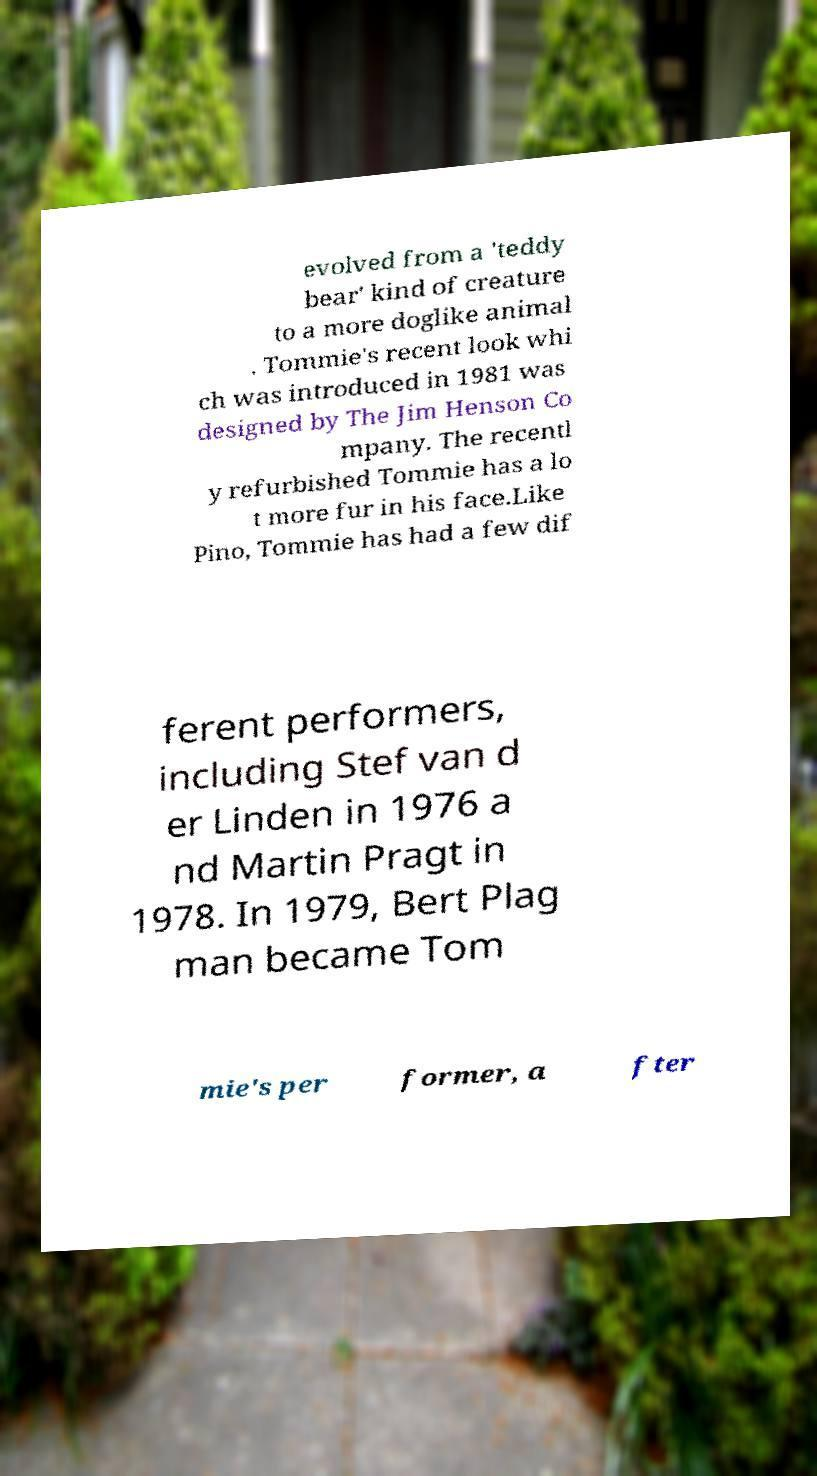What messages or text are displayed in this image? I need them in a readable, typed format. evolved from a 'teddy bear' kind of creature to a more doglike animal . Tommie's recent look whi ch was introduced in 1981 was designed by The Jim Henson Co mpany. The recentl y refurbished Tommie has a lo t more fur in his face.Like Pino, Tommie has had a few dif ferent performers, including Stef van d er Linden in 1976 a nd Martin Pragt in 1978. In 1979, Bert Plag man became Tom mie's per former, a fter 